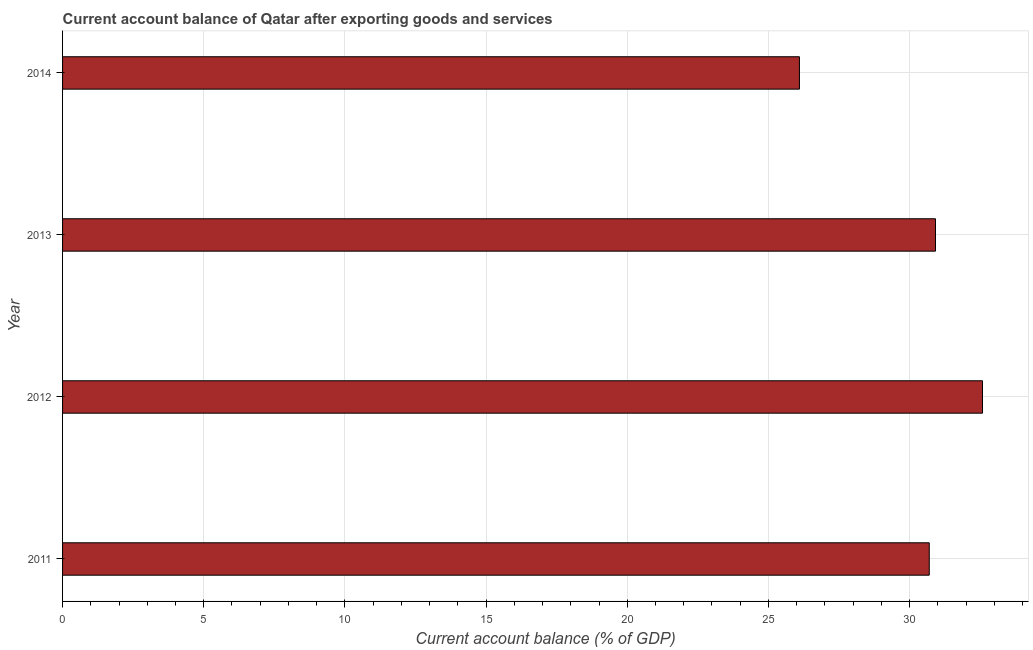What is the title of the graph?
Provide a short and direct response. Current account balance of Qatar after exporting goods and services. What is the label or title of the X-axis?
Give a very brief answer. Current account balance (% of GDP). What is the current account balance in 2012?
Ensure brevity in your answer.  32.58. Across all years, what is the maximum current account balance?
Make the answer very short. 32.58. Across all years, what is the minimum current account balance?
Your answer should be compact. 26.1. In which year was the current account balance minimum?
Your response must be concise. 2014. What is the sum of the current account balance?
Your answer should be compact. 120.29. What is the difference between the current account balance in 2011 and 2014?
Your answer should be compact. 4.6. What is the average current account balance per year?
Offer a terse response. 30.07. What is the median current account balance?
Your answer should be very brief. 30.81. Do a majority of the years between 2011 and 2012 (inclusive) have current account balance greater than 11 %?
Offer a terse response. Yes. What is the ratio of the current account balance in 2012 to that in 2013?
Your answer should be very brief. 1.05. Is the current account balance in 2011 less than that in 2013?
Your answer should be compact. Yes. Is the difference between the current account balance in 2011 and 2013 greater than the difference between any two years?
Give a very brief answer. No. What is the difference between the highest and the second highest current account balance?
Your answer should be very brief. 1.67. Is the sum of the current account balance in 2011 and 2012 greater than the maximum current account balance across all years?
Offer a very short reply. Yes. What is the difference between the highest and the lowest current account balance?
Make the answer very short. 6.48. How many bars are there?
Provide a short and direct response. 4. Are all the bars in the graph horizontal?
Your response must be concise. Yes. How many years are there in the graph?
Provide a succinct answer. 4. What is the difference between two consecutive major ticks on the X-axis?
Offer a very short reply. 5. Are the values on the major ticks of X-axis written in scientific E-notation?
Provide a succinct answer. No. What is the Current account balance (% of GDP) of 2011?
Give a very brief answer. 30.7. What is the Current account balance (% of GDP) in 2012?
Your response must be concise. 32.58. What is the Current account balance (% of GDP) in 2013?
Offer a very short reply. 30.92. What is the Current account balance (% of GDP) in 2014?
Offer a terse response. 26.1. What is the difference between the Current account balance (% of GDP) in 2011 and 2012?
Provide a succinct answer. -1.89. What is the difference between the Current account balance (% of GDP) in 2011 and 2013?
Your answer should be very brief. -0.22. What is the difference between the Current account balance (% of GDP) in 2011 and 2014?
Your answer should be very brief. 4.6. What is the difference between the Current account balance (% of GDP) in 2012 and 2013?
Keep it short and to the point. 1.66. What is the difference between the Current account balance (% of GDP) in 2012 and 2014?
Offer a very short reply. 6.48. What is the difference between the Current account balance (% of GDP) in 2013 and 2014?
Your answer should be very brief. 4.82. What is the ratio of the Current account balance (% of GDP) in 2011 to that in 2012?
Your answer should be compact. 0.94. What is the ratio of the Current account balance (% of GDP) in 2011 to that in 2013?
Keep it short and to the point. 0.99. What is the ratio of the Current account balance (% of GDP) in 2011 to that in 2014?
Ensure brevity in your answer.  1.18. What is the ratio of the Current account balance (% of GDP) in 2012 to that in 2013?
Give a very brief answer. 1.05. What is the ratio of the Current account balance (% of GDP) in 2012 to that in 2014?
Provide a short and direct response. 1.25. What is the ratio of the Current account balance (% of GDP) in 2013 to that in 2014?
Your response must be concise. 1.19. 